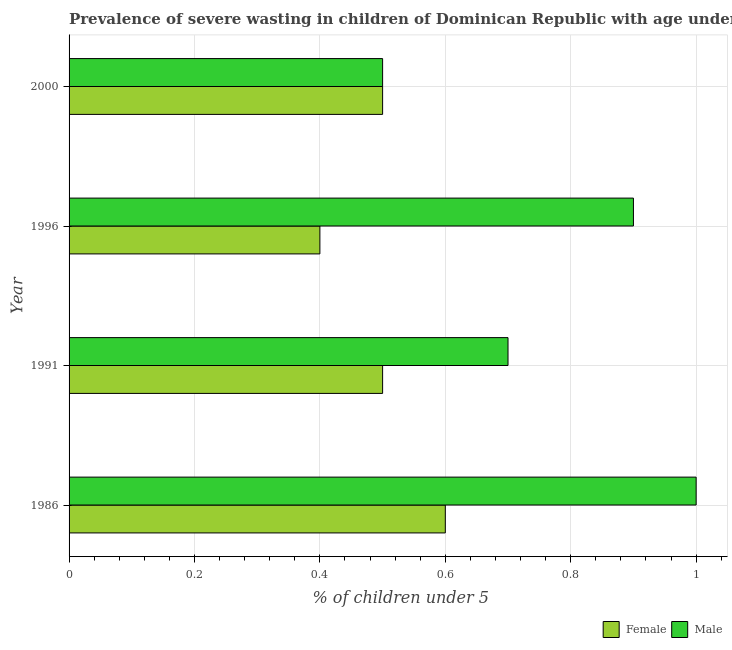Are the number of bars per tick equal to the number of legend labels?
Ensure brevity in your answer.  Yes. Are the number of bars on each tick of the Y-axis equal?
Offer a terse response. Yes. How many bars are there on the 4th tick from the top?
Make the answer very short. 2. How many bars are there on the 3rd tick from the bottom?
Your answer should be very brief. 2. Across all years, what is the maximum percentage of undernourished male children?
Your response must be concise. 1. Across all years, what is the minimum percentage of undernourished male children?
Offer a terse response. 0.5. In which year was the percentage of undernourished male children minimum?
Offer a very short reply. 2000. What is the total percentage of undernourished female children in the graph?
Provide a short and direct response. 2. What is the difference between the percentage of undernourished female children in 1986 and that in 1996?
Provide a succinct answer. 0.2. What is the difference between the percentage of undernourished female children in 1996 and the percentage of undernourished male children in 1991?
Provide a short and direct response. -0.3. What is the average percentage of undernourished male children per year?
Your response must be concise. 0.78. What is the ratio of the percentage of undernourished male children in 1986 to that in 2000?
Give a very brief answer. 2. Is the percentage of undernourished female children in 1986 less than that in 2000?
Make the answer very short. No. What is the difference between the highest and the lowest percentage of undernourished female children?
Offer a terse response. 0.2. Is the sum of the percentage of undernourished female children in 1991 and 2000 greater than the maximum percentage of undernourished male children across all years?
Offer a terse response. No. What does the 2nd bar from the bottom in 1996 represents?
Keep it short and to the point. Male. How many bars are there?
Keep it short and to the point. 8. What is the difference between two consecutive major ticks on the X-axis?
Offer a very short reply. 0.2. Does the graph contain grids?
Provide a succinct answer. Yes. Where does the legend appear in the graph?
Make the answer very short. Bottom right. How many legend labels are there?
Offer a terse response. 2. What is the title of the graph?
Your answer should be very brief. Prevalence of severe wasting in children of Dominican Republic with age under 5 years. What is the label or title of the X-axis?
Give a very brief answer.  % of children under 5. What is the label or title of the Y-axis?
Offer a very short reply. Year. What is the  % of children under 5 in Female in 1986?
Ensure brevity in your answer.  0.6. What is the  % of children under 5 in Male in 1991?
Your response must be concise. 0.7. What is the  % of children under 5 in Female in 1996?
Give a very brief answer. 0.4. What is the  % of children under 5 of Male in 1996?
Give a very brief answer. 0.9. Across all years, what is the maximum  % of children under 5 in Female?
Provide a succinct answer. 0.6. Across all years, what is the maximum  % of children under 5 of Male?
Your response must be concise. 1. Across all years, what is the minimum  % of children under 5 in Female?
Provide a succinct answer. 0.4. What is the difference between the  % of children under 5 in Male in 1986 and that in 1996?
Your answer should be compact. 0.1. What is the difference between the  % of children under 5 in Female in 1991 and that in 1996?
Offer a terse response. 0.1. What is the difference between the  % of children under 5 of Male in 1991 and that in 1996?
Provide a short and direct response. -0.2. What is the difference between the  % of children under 5 in Female in 1991 and that in 2000?
Give a very brief answer. 0. What is the difference between the  % of children under 5 in Female in 1996 and that in 2000?
Offer a very short reply. -0.1. What is the difference between the  % of children under 5 in Male in 1996 and that in 2000?
Offer a very short reply. 0.4. What is the difference between the  % of children under 5 of Female in 1986 and the  % of children under 5 of Male in 1996?
Ensure brevity in your answer.  -0.3. What is the difference between the  % of children under 5 of Female in 1986 and the  % of children under 5 of Male in 2000?
Keep it short and to the point. 0.1. What is the difference between the  % of children under 5 of Female in 1991 and the  % of children under 5 of Male in 1996?
Offer a terse response. -0.4. What is the difference between the  % of children under 5 of Female in 1991 and the  % of children under 5 of Male in 2000?
Keep it short and to the point. 0. What is the difference between the  % of children under 5 in Female in 1996 and the  % of children under 5 in Male in 2000?
Ensure brevity in your answer.  -0.1. What is the average  % of children under 5 of Female per year?
Offer a very short reply. 0.5. What is the average  % of children under 5 in Male per year?
Provide a short and direct response. 0.78. In the year 1986, what is the difference between the  % of children under 5 in Female and  % of children under 5 in Male?
Your response must be concise. -0.4. In the year 1991, what is the difference between the  % of children under 5 of Female and  % of children under 5 of Male?
Keep it short and to the point. -0.2. In the year 1996, what is the difference between the  % of children under 5 in Female and  % of children under 5 in Male?
Your answer should be very brief. -0.5. What is the ratio of the  % of children under 5 of Male in 1986 to that in 1991?
Provide a short and direct response. 1.43. What is the ratio of the  % of children under 5 in Female in 1986 to that in 1996?
Your answer should be compact. 1.5. What is the ratio of the  % of children under 5 in Female in 1986 to that in 2000?
Keep it short and to the point. 1.2. What is the ratio of the  % of children under 5 in Male in 1991 to that in 1996?
Your answer should be compact. 0.78. What is the ratio of the  % of children under 5 in Female in 1991 to that in 2000?
Your answer should be compact. 1. What is the ratio of the  % of children under 5 in Male in 1996 to that in 2000?
Give a very brief answer. 1.8. What is the difference between the highest and the second highest  % of children under 5 of Female?
Your response must be concise. 0.1. What is the difference between the highest and the lowest  % of children under 5 of Female?
Provide a short and direct response. 0.2. What is the difference between the highest and the lowest  % of children under 5 in Male?
Offer a terse response. 0.5. 